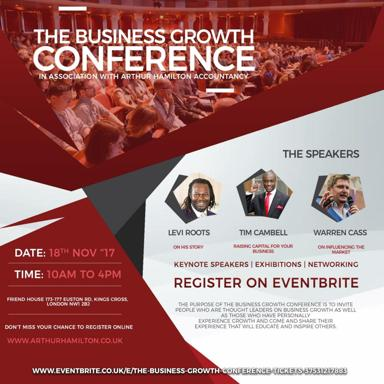Where can people register for the event? Interested individuals can register for The Business Growth Conference via the Arthur Hamilton website at www.arthurhamilton.co.uk or directly through Eventbrite at www.eventbrite.co.uk. These platforms facilitate easy registration, ensuring attendees can secure their spot promptly. 